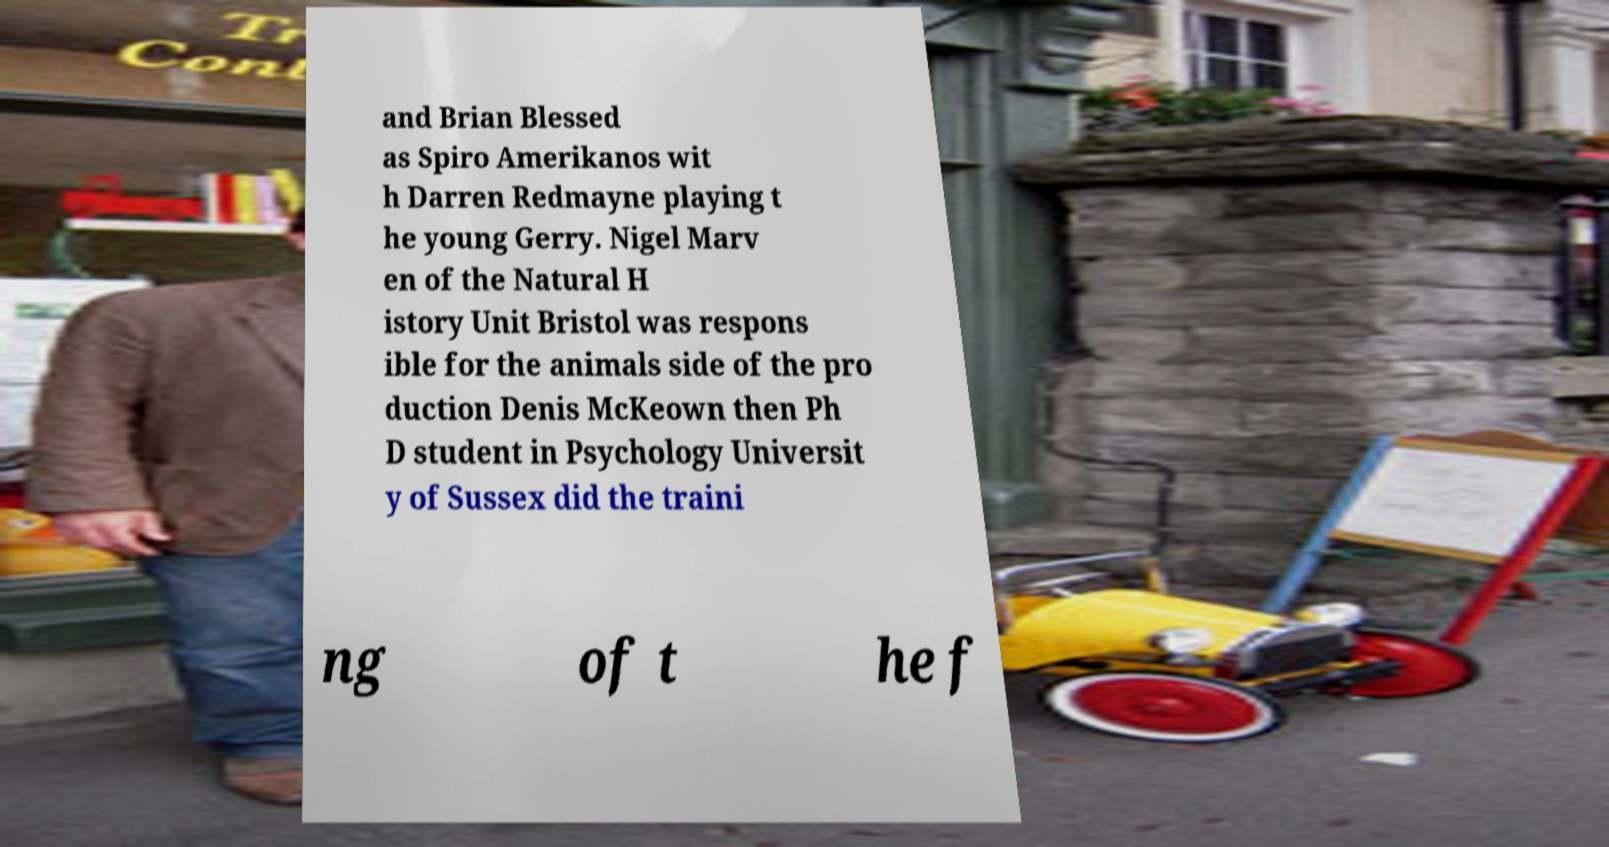There's text embedded in this image that I need extracted. Can you transcribe it verbatim? and Brian Blessed as Spiro Amerikanos wit h Darren Redmayne playing t he young Gerry. Nigel Marv en of the Natural H istory Unit Bristol was respons ible for the animals side of the pro duction Denis McKeown then Ph D student in Psychology Universit y of Sussex did the traini ng of t he f 